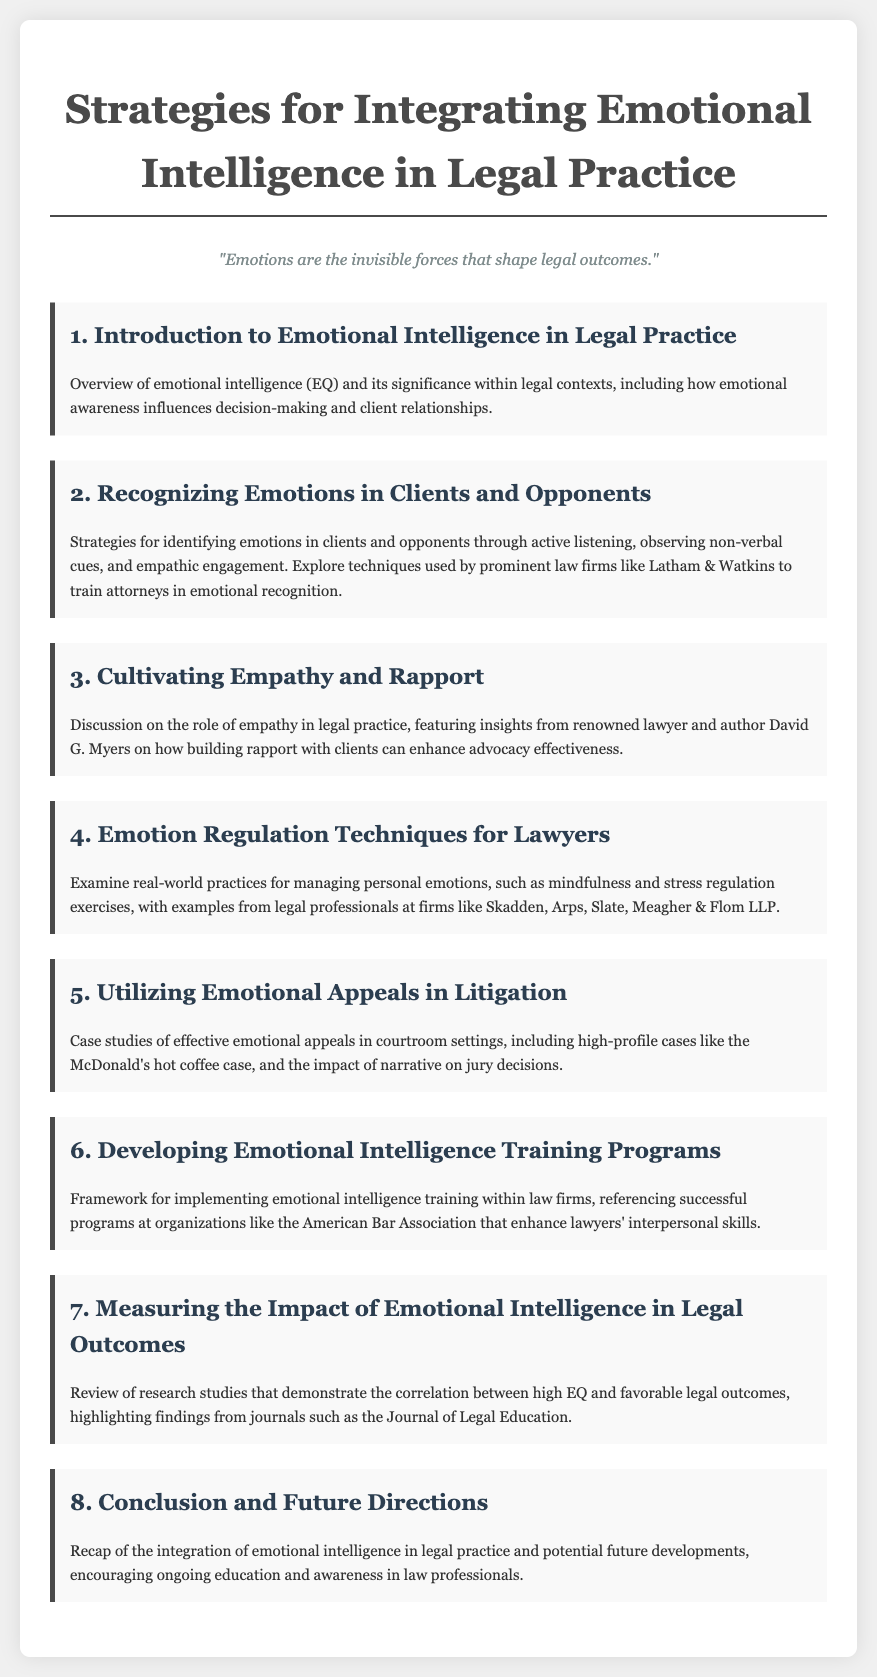What is the title of the agenda? The title is clearly stated at the top of the document, which is focused on strategies for emotional intelligence in legal practice.
Answer: Strategies for Integrating Emotional Intelligence in Legal Practice Who is a renowned lawyer and author mentioned in the document? The document specifies David G. Myers as a notable figure in the discussion about empathy in legal practice.
Answer: David G. Myers What is the focus of the fifth agenda item? The fifth agenda item discusses the use of emotional appeals during litigation, supported by case studies.
Answer: Utilizing Emotional Appeals in Litigation What training framework is referenced in the sixth agenda item? The sixth agenda item outlines the framework for implementing emotional intelligence training, referring to existing programs for enhancing skills.
Answer: Developing Emotional Intelligence Training Programs Which firm is noted for training attorneys in emotional recognition? The document mentions Latham & Watkins as a law firm that uses strategies for training attorneys in recognizing emotions.
Answer: Latham & Watkins What is a key technique mentioned for managing emotions? The document indicates mindfulness as a practice for emotional regulation among lawyers.
Answer: Mindfulness How many main agenda items are listed in the document? There are eight distinct agenda items outlined in the document's structure addressing emotional intelligence.
Answer: Eight 